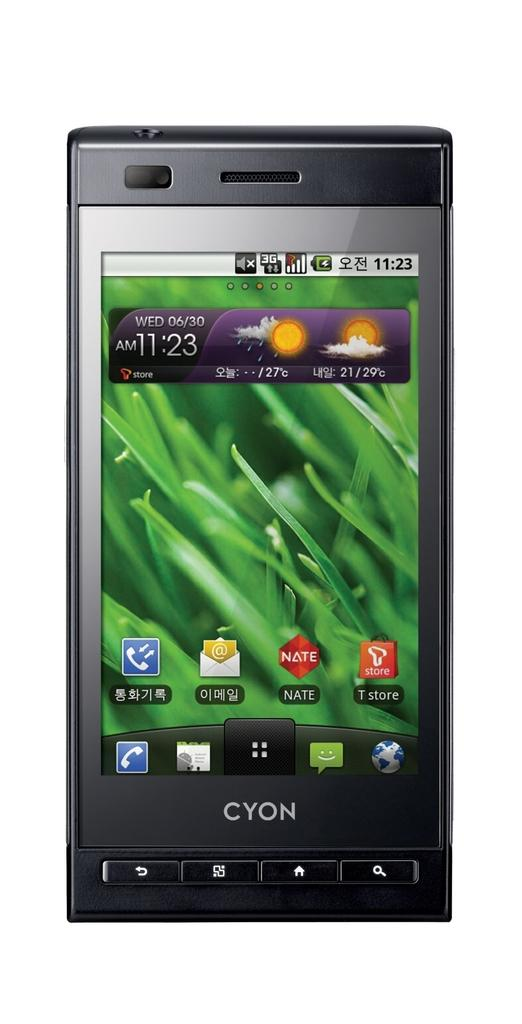<image>
Relay a brief, clear account of the picture shown. A cellphone by Cyon is turned on and displays the desktop with the weather and various application icons. 